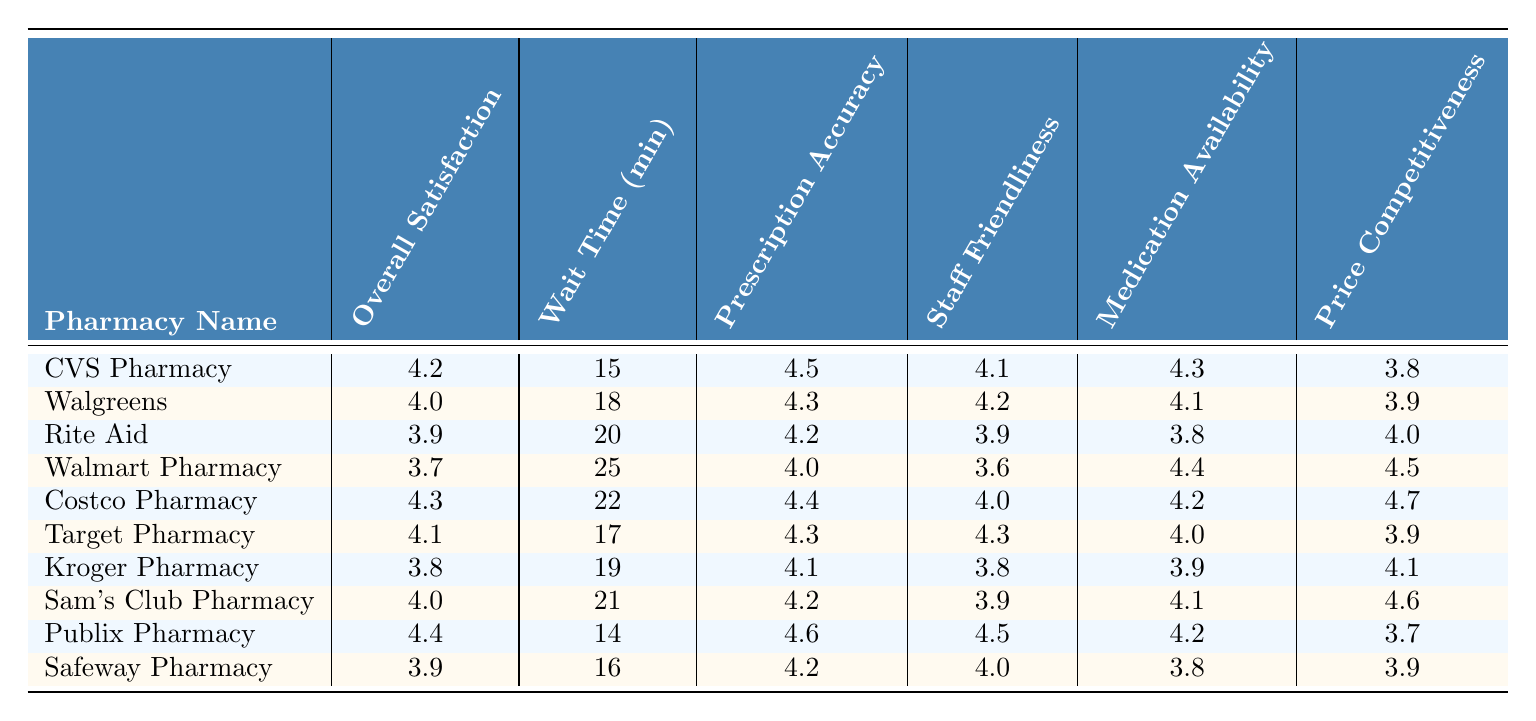What is the Overall Satisfaction Rating of Publix Pharmacy? The Overall Satisfaction Rating for Publix Pharmacy is listed in the table under the "Overall Satisfaction Rating" column. The value is 4.4.
Answer: 4.4 Which pharmacy has the shortest Wait Time? By looking at the "Wait Time (minutes)" column, Publix Pharmacy has the shortest wait time of 14 minutes compared to the others.
Answer: Publix Pharmacy What is the Prescription Accuracy rating for Walmart Pharmacy? The Prescription Accuracy for Walmart Pharmacy can be found in the "Prescription Accuracy" column, which shows a rating of 4.0.
Answer: 4.0 How many pharmacies have a Wait Time of 20 minutes or more? The "Wait Time (minutes)" column indicates that there are 3 pharmacies (Walmart Pharmacy, Rite Aid, and Sam's Club Pharmacy) with wait times of 20 minutes or more.
Answer: 3 Is the Overall Satisfaction Rating of CVS Pharmacy higher than that of Walgreens? The Overall Satisfaction Rating for CVS Pharmacy is 4.2 and for Walgreens is 4.0, so CVS Pharmacy has a higher rating.
Answer: Yes What is the average Wait Time across all the pharmacies listed? To find the average Wait Time, sum the wait times: (15 + 18 + 20 + 25 + 22 + 17 + 19 + 21 + 14 + 16) =  195 minutes. There are 10 pharmacies, thus the average is 195/10 = 19.5 minutes.
Answer: 19.5 Which pharmacy has the highest Staff Friendliness rating? Looking through the "Staff Friendliness" column, Publix Pharmacy has the highest rating at 4.5.
Answer: Publix Pharmacy Is the Price Competitiveness rating for Costco Pharmacy above or below 4.0? The Price Competitiveness for Costco Pharmacy is 4.7, which is above 4.0.
Answer: Above What is the difference in Overall Satisfaction Rating between the highest and lowest rated pharmacies? The highest rating is for Publix Pharmacy (4.4) and the lowest is for Walmart Pharmacy (3.7). The difference is 4.4 - 3.7 = 0.7.
Answer: 0.7 How does the Price Competitiveness of Safeway Pharmacy compare to that of Kroger Pharmacy? Safeway Pharmacy has a Price Competitiveness rating of 3.9, while Kroger Pharmacy has a rating of 4.1. Kroger Pharmacy is higher.
Answer: Kroger Pharmacy is higher 